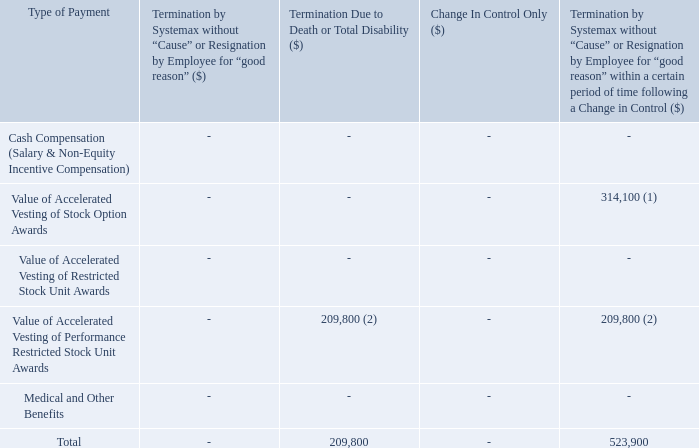Thomas Clark
(1) Represents accelerated vesting of 33,711 stock options. Pursuant to Mr. Clark’s stock option agreements (dated January 17, 2019), if Mr. Clark’s employment is terminated without cause or for good reason within six months following a “change in control”, he will become immediately vested in all outstanding unvested stock options, and all of Mr. Clark’s outstanding options shall remain exercisable in accordance with their terms, but in no event for less than 90 days after such termination. (1) Represents accelerated vesting of 33,711 stock options. Pursuant to Mr. Clark’s stock option agreements (dated January 17, 2019), if Mr. Clark’s employment is terminated without cause or for good reason within six months following a “change in control”, he will become immediately vested in all outstanding unvested stock options, and all of Mr. Clark’s outstanding options shall remain exercisable in accordance with their terms, but in no event for less than 90 days after such termination. (1) Represents accelerated vesting of 33,711 stock options. Pursuant to Mr. Clark’s stock option agreements (dated January 17, 2019), if Mr. Clark’s employment is terminated without cause or for good reason within six months following a “change in control”, he will become immediately vested in all outstanding unvested stock options, and all of Mr. Clark’s outstanding options shall remain exercisable in accordance with their terms, but in no event for less than 90 days after such termination.
(2) Represents accelerated vesting of 8,340 unvested performance restricted stock units. Pursuant to Mr. Clark’s performance restricted stock unit agreement (dated January 17, 2019), if Mr. Clark’s employment is terminated without cause or for good reason within six months following a “change in control” or if Mr. Clark's employment is terminated due to death or total disability, all non-vested units shall accelerate and be vested as of the date of termination.
What are the Thomas Clark's accelerated vesting of stock options and unvested performance restricted stock units respectively? 33,711, 8,340. What is the total termination due to Thomas Clark as a result of death or termination by Systemax without cause respectively? 209,800, 523,900. What is the value of Thomas Clark's medical and other benefits and Accelerated Vesting of Stock Option Awards respectively? 0, 0. What is the value of accelerated vesting of stock option awards as a percentage of the total payments made as a result of termination by Systemax without cause within a certain period of time following a Change in Control?
Answer scale should be: percent. 314,100/523,900 
Answer: 59.95. What is the total termination due to Thomas Clark as a result of death or termination by Systemax without cause within a certain period of time following a Change in Control? 209,800 + 523,900 
Answer: 733700. What is the proportion of total payment as a result of termination due to death as a percentage of the overall payment due to Thomas Clark?
Answer scale should be: percent. 209,800/ (209,800 + 523,900) 
Answer: 28.59. 